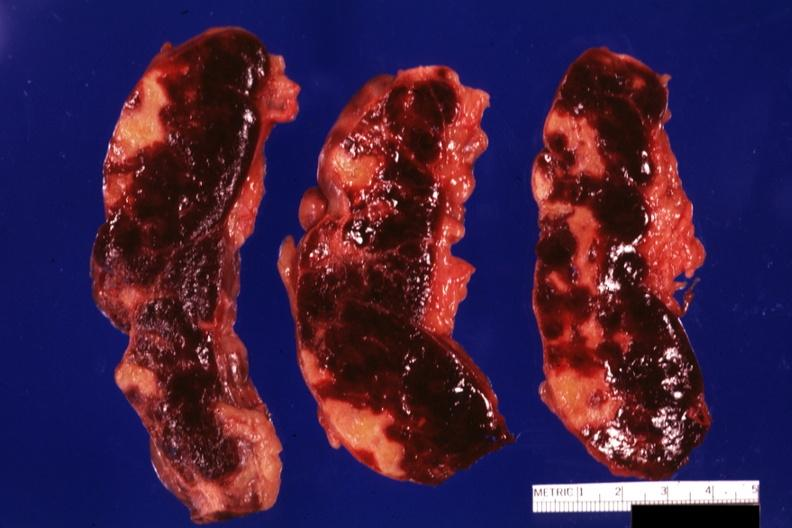does cardiovascular show three cut sections many lesions several days of age?
Answer the question using a single word or phrase. No 